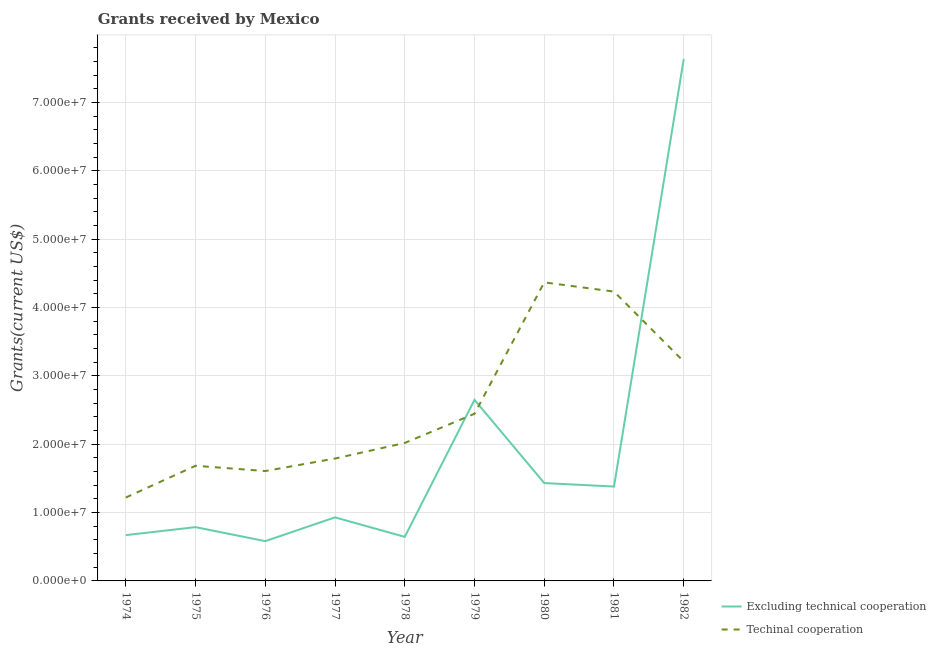What is the amount of grants received(excluding technical cooperation) in 1980?
Your answer should be compact. 1.43e+07. Across all years, what is the maximum amount of grants received(excluding technical cooperation)?
Offer a very short reply. 7.64e+07. Across all years, what is the minimum amount of grants received(excluding technical cooperation)?
Ensure brevity in your answer.  5.82e+06. In which year was the amount of grants received(including technical cooperation) maximum?
Keep it short and to the point. 1980. In which year was the amount of grants received(excluding technical cooperation) minimum?
Keep it short and to the point. 1976. What is the total amount of grants received(including technical cooperation) in the graph?
Provide a short and direct response. 2.26e+08. What is the difference between the amount of grants received(including technical cooperation) in 1974 and that in 1978?
Provide a succinct answer. -7.99e+06. What is the difference between the amount of grants received(excluding technical cooperation) in 1974 and the amount of grants received(including technical cooperation) in 1981?
Your answer should be very brief. -3.56e+07. What is the average amount of grants received(excluding technical cooperation) per year?
Offer a very short reply. 1.86e+07. In the year 1974, what is the difference between the amount of grants received(excluding technical cooperation) and amount of grants received(including technical cooperation)?
Provide a short and direct response. -5.50e+06. What is the ratio of the amount of grants received(excluding technical cooperation) in 1975 to that in 1982?
Ensure brevity in your answer.  0.1. What is the difference between the highest and the second highest amount of grants received(including technical cooperation)?
Your response must be concise. 1.35e+06. What is the difference between the highest and the lowest amount of grants received(including technical cooperation)?
Ensure brevity in your answer.  3.15e+07. In how many years, is the amount of grants received(excluding technical cooperation) greater than the average amount of grants received(excluding technical cooperation) taken over all years?
Keep it short and to the point. 2. How many lines are there?
Offer a terse response. 2. How many years are there in the graph?
Provide a short and direct response. 9. Are the values on the major ticks of Y-axis written in scientific E-notation?
Your response must be concise. Yes. Does the graph contain any zero values?
Offer a terse response. No. Where does the legend appear in the graph?
Provide a short and direct response. Bottom right. How are the legend labels stacked?
Give a very brief answer. Vertical. What is the title of the graph?
Your response must be concise. Grants received by Mexico. Does "Nitrous oxide emissions" appear as one of the legend labels in the graph?
Your answer should be very brief. No. What is the label or title of the Y-axis?
Offer a very short reply. Grants(current US$). What is the Grants(current US$) of Excluding technical cooperation in 1974?
Give a very brief answer. 6.70e+06. What is the Grants(current US$) in Techinal cooperation in 1974?
Your answer should be compact. 1.22e+07. What is the Grants(current US$) in Excluding technical cooperation in 1975?
Make the answer very short. 7.87e+06. What is the Grants(current US$) of Techinal cooperation in 1975?
Your answer should be compact. 1.68e+07. What is the Grants(current US$) of Excluding technical cooperation in 1976?
Provide a succinct answer. 5.82e+06. What is the Grants(current US$) of Techinal cooperation in 1976?
Your answer should be very brief. 1.61e+07. What is the Grants(current US$) in Excluding technical cooperation in 1977?
Ensure brevity in your answer.  9.30e+06. What is the Grants(current US$) of Techinal cooperation in 1977?
Ensure brevity in your answer.  1.79e+07. What is the Grants(current US$) in Excluding technical cooperation in 1978?
Ensure brevity in your answer.  6.45e+06. What is the Grants(current US$) in Techinal cooperation in 1978?
Give a very brief answer. 2.02e+07. What is the Grants(current US$) of Excluding technical cooperation in 1979?
Offer a terse response. 2.65e+07. What is the Grants(current US$) of Techinal cooperation in 1979?
Give a very brief answer. 2.45e+07. What is the Grants(current US$) of Excluding technical cooperation in 1980?
Offer a terse response. 1.43e+07. What is the Grants(current US$) in Techinal cooperation in 1980?
Provide a succinct answer. 4.37e+07. What is the Grants(current US$) of Excluding technical cooperation in 1981?
Your answer should be very brief. 1.38e+07. What is the Grants(current US$) in Techinal cooperation in 1981?
Provide a short and direct response. 4.23e+07. What is the Grants(current US$) in Excluding technical cooperation in 1982?
Your answer should be very brief. 7.64e+07. What is the Grants(current US$) of Techinal cooperation in 1982?
Offer a terse response. 3.21e+07. Across all years, what is the maximum Grants(current US$) in Excluding technical cooperation?
Provide a short and direct response. 7.64e+07. Across all years, what is the maximum Grants(current US$) in Techinal cooperation?
Offer a terse response. 4.37e+07. Across all years, what is the minimum Grants(current US$) in Excluding technical cooperation?
Keep it short and to the point. 5.82e+06. Across all years, what is the minimum Grants(current US$) in Techinal cooperation?
Provide a succinct answer. 1.22e+07. What is the total Grants(current US$) in Excluding technical cooperation in the graph?
Your response must be concise. 1.67e+08. What is the total Grants(current US$) of Techinal cooperation in the graph?
Provide a succinct answer. 2.26e+08. What is the difference between the Grants(current US$) of Excluding technical cooperation in 1974 and that in 1975?
Your answer should be compact. -1.17e+06. What is the difference between the Grants(current US$) in Techinal cooperation in 1974 and that in 1975?
Ensure brevity in your answer.  -4.65e+06. What is the difference between the Grants(current US$) of Excluding technical cooperation in 1974 and that in 1976?
Ensure brevity in your answer.  8.80e+05. What is the difference between the Grants(current US$) of Techinal cooperation in 1974 and that in 1976?
Keep it short and to the point. -3.88e+06. What is the difference between the Grants(current US$) of Excluding technical cooperation in 1974 and that in 1977?
Your answer should be compact. -2.60e+06. What is the difference between the Grants(current US$) in Techinal cooperation in 1974 and that in 1977?
Offer a terse response. -5.71e+06. What is the difference between the Grants(current US$) of Excluding technical cooperation in 1974 and that in 1978?
Provide a succinct answer. 2.50e+05. What is the difference between the Grants(current US$) of Techinal cooperation in 1974 and that in 1978?
Provide a succinct answer. -7.99e+06. What is the difference between the Grants(current US$) in Excluding technical cooperation in 1974 and that in 1979?
Provide a succinct answer. -1.98e+07. What is the difference between the Grants(current US$) of Techinal cooperation in 1974 and that in 1979?
Provide a short and direct response. -1.23e+07. What is the difference between the Grants(current US$) of Excluding technical cooperation in 1974 and that in 1980?
Keep it short and to the point. -7.62e+06. What is the difference between the Grants(current US$) of Techinal cooperation in 1974 and that in 1980?
Offer a terse response. -3.15e+07. What is the difference between the Grants(current US$) in Excluding technical cooperation in 1974 and that in 1981?
Your answer should be very brief. -7.11e+06. What is the difference between the Grants(current US$) in Techinal cooperation in 1974 and that in 1981?
Your answer should be very brief. -3.01e+07. What is the difference between the Grants(current US$) of Excluding technical cooperation in 1974 and that in 1982?
Your answer should be very brief. -6.97e+07. What is the difference between the Grants(current US$) in Techinal cooperation in 1974 and that in 1982?
Your answer should be compact. -1.99e+07. What is the difference between the Grants(current US$) of Excluding technical cooperation in 1975 and that in 1976?
Offer a very short reply. 2.05e+06. What is the difference between the Grants(current US$) in Techinal cooperation in 1975 and that in 1976?
Offer a very short reply. 7.70e+05. What is the difference between the Grants(current US$) of Excluding technical cooperation in 1975 and that in 1977?
Your answer should be very brief. -1.43e+06. What is the difference between the Grants(current US$) of Techinal cooperation in 1975 and that in 1977?
Provide a short and direct response. -1.06e+06. What is the difference between the Grants(current US$) in Excluding technical cooperation in 1975 and that in 1978?
Provide a short and direct response. 1.42e+06. What is the difference between the Grants(current US$) in Techinal cooperation in 1975 and that in 1978?
Keep it short and to the point. -3.34e+06. What is the difference between the Grants(current US$) in Excluding technical cooperation in 1975 and that in 1979?
Your response must be concise. -1.86e+07. What is the difference between the Grants(current US$) of Techinal cooperation in 1975 and that in 1979?
Provide a short and direct response. -7.61e+06. What is the difference between the Grants(current US$) in Excluding technical cooperation in 1975 and that in 1980?
Your response must be concise. -6.45e+06. What is the difference between the Grants(current US$) of Techinal cooperation in 1975 and that in 1980?
Ensure brevity in your answer.  -2.68e+07. What is the difference between the Grants(current US$) of Excluding technical cooperation in 1975 and that in 1981?
Provide a succinct answer. -5.94e+06. What is the difference between the Grants(current US$) in Techinal cooperation in 1975 and that in 1981?
Make the answer very short. -2.55e+07. What is the difference between the Grants(current US$) of Excluding technical cooperation in 1975 and that in 1982?
Provide a succinct answer. -6.85e+07. What is the difference between the Grants(current US$) of Techinal cooperation in 1975 and that in 1982?
Offer a terse response. -1.53e+07. What is the difference between the Grants(current US$) in Excluding technical cooperation in 1976 and that in 1977?
Keep it short and to the point. -3.48e+06. What is the difference between the Grants(current US$) in Techinal cooperation in 1976 and that in 1977?
Your answer should be compact. -1.83e+06. What is the difference between the Grants(current US$) in Excluding technical cooperation in 1976 and that in 1978?
Give a very brief answer. -6.30e+05. What is the difference between the Grants(current US$) of Techinal cooperation in 1976 and that in 1978?
Provide a short and direct response. -4.11e+06. What is the difference between the Grants(current US$) of Excluding technical cooperation in 1976 and that in 1979?
Make the answer very short. -2.07e+07. What is the difference between the Grants(current US$) of Techinal cooperation in 1976 and that in 1979?
Provide a succinct answer. -8.38e+06. What is the difference between the Grants(current US$) in Excluding technical cooperation in 1976 and that in 1980?
Give a very brief answer. -8.50e+06. What is the difference between the Grants(current US$) of Techinal cooperation in 1976 and that in 1980?
Make the answer very short. -2.76e+07. What is the difference between the Grants(current US$) of Excluding technical cooperation in 1976 and that in 1981?
Your response must be concise. -7.99e+06. What is the difference between the Grants(current US$) in Techinal cooperation in 1976 and that in 1981?
Keep it short and to the point. -2.63e+07. What is the difference between the Grants(current US$) in Excluding technical cooperation in 1976 and that in 1982?
Offer a terse response. -7.06e+07. What is the difference between the Grants(current US$) of Techinal cooperation in 1976 and that in 1982?
Keep it short and to the point. -1.60e+07. What is the difference between the Grants(current US$) of Excluding technical cooperation in 1977 and that in 1978?
Your answer should be compact. 2.85e+06. What is the difference between the Grants(current US$) in Techinal cooperation in 1977 and that in 1978?
Offer a very short reply. -2.28e+06. What is the difference between the Grants(current US$) in Excluding technical cooperation in 1977 and that in 1979?
Your response must be concise. -1.72e+07. What is the difference between the Grants(current US$) of Techinal cooperation in 1977 and that in 1979?
Ensure brevity in your answer.  -6.55e+06. What is the difference between the Grants(current US$) in Excluding technical cooperation in 1977 and that in 1980?
Provide a succinct answer. -5.02e+06. What is the difference between the Grants(current US$) of Techinal cooperation in 1977 and that in 1980?
Offer a terse response. -2.58e+07. What is the difference between the Grants(current US$) in Excluding technical cooperation in 1977 and that in 1981?
Provide a short and direct response. -4.51e+06. What is the difference between the Grants(current US$) of Techinal cooperation in 1977 and that in 1981?
Provide a short and direct response. -2.44e+07. What is the difference between the Grants(current US$) of Excluding technical cooperation in 1977 and that in 1982?
Your answer should be very brief. -6.71e+07. What is the difference between the Grants(current US$) of Techinal cooperation in 1977 and that in 1982?
Make the answer very short. -1.42e+07. What is the difference between the Grants(current US$) of Excluding technical cooperation in 1978 and that in 1979?
Your answer should be very brief. -2.00e+07. What is the difference between the Grants(current US$) in Techinal cooperation in 1978 and that in 1979?
Your response must be concise. -4.27e+06. What is the difference between the Grants(current US$) of Excluding technical cooperation in 1978 and that in 1980?
Give a very brief answer. -7.87e+06. What is the difference between the Grants(current US$) of Techinal cooperation in 1978 and that in 1980?
Offer a very short reply. -2.35e+07. What is the difference between the Grants(current US$) in Excluding technical cooperation in 1978 and that in 1981?
Offer a terse response. -7.36e+06. What is the difference between the Grants(current US$) in Techinal cooperation in 1978 and that in 1981?
Your answer should be compact. -2.22e+07. What is the difference between the Grants(current US$) in Excluding technical cooperation in 1978 and that in 1982?
Give a very brief answer. -6.99e+07. What is the difference between the Grants(current US$) of Techinal cooperation in 1978 and that in 1982?
Offer a very short reply. -1.19e+07. What is the difference between the Grants(current US$) of Excluding technical cooperation in 1979 and that in 1980?
Keep it short and to the point. 1.22e+07. What is the difference between the Grants(current US$) in Techinal cooperation in 1979 and that in 1980?
Your response must be concise. -1.92e+07. What is the difference between the Grants(current US$) of Excluding technical cooperation in 1979 and that in 1981?
Offer a very short reply. 1.27e+07. What is the difference between the Grants(current US$) of Techinal cooperation in 1979 and that in 1981?
Provide a short and direct response. -1.79e+07. What is the difference between the Grants(current US$) of Excluding technical cooperation in 1979 and that in 1982?
Your response must be concise. -4.99e+07. What is the difference between the Grants(current US$) in Techinal cooperation in 1979 and that in 1982?
Your answer should be very brief. -7.65e+06. What is the difference between the Grants(current US$) of Excluding technical cooperation in 1980 and that in 1981?
Your response must be concise. 5.10e+05. What is the difference between the Grants(current US$) of Techinal cooperation in 1980 and that in 1981?
Ensure brevity in your answer.  1.35e+06. What is the difference between the Grants(current US$) of Excluding technical cooperation in 1980 and that in 1982?
Your response must be concise. -6.21e+07. What is the difference between the Grants(current US$) of Techinal cooperation in 1980 and that in 1982?
Your response must be concise. 1.16e+07. What is the difference between the Grants(current US$) in Excluding technical cooperation in 1981 and that in 1982?
Your response must be concise. -6.26e+07. What is the difference between the Grants(current US$) of Techinal cooperation in 1981 and that in 1982?
Offer a terse response. 1.02e+07. What is the difference between the Grants(current US$) in Excluding technical cooperation in 1974 and the Grants(current US$) in Techinal cooperation in 1975?
Your response must be concise. -1.02e+07. What is the difference between the Grants(current US$) in Excluding technical cooperation in 1974 and the Grants(current US$) in Techinal cooperation in 1976?
Give a very brief answer. -9.38e+06. What is the difference between the Grants(current US$) of Excluding technical cooperation in 1974 and the Grants(current US$) of Techinal cooperation in 1977?
Your answer should be very brief. -1.12e+07. What is the difference between the Grants(current US$) in Excluding technical cooperation in 1974 and the Grants(current US$) in Techinal cooperation in 1978?
Your answer should be compact. -1.35e+07. What is the difference between the Grants(current US$) of Excluding technical cooperation in 1974 and the Grants(current US$) of Techinal cooperation in 1979?
Provide a short and direct response. -1.78e+07. What is the difference between the Grants(current US$) of Excluding technical cooperation in 1974 and the Grants(current US$) of Techinal cooperation in 1980?
Provide a short and direct response. -3.70e+07. What is the difference between the Grants(current US$) of Excluding technical cooperation in 1974 and the Grants(current US$) of Techinal cooperation in 1981?
Ensure brevity in your answer.  -3.56e+07. What is the difference between the Grants(current US$) in Excluding technical cooperation in 1974 and the Grants(current US$) in Techinal cooperation in 1982?
Keep it short and to the point. -2.54e+07. What is the difference between the Grants(current US$) in Excluding technical cooperation in 1975 and the Grants(current US$) in Techinal cooperation in 1976?
Make the answer very short. -8.21e+06. What is the difference between the Grants(current US$) in Excluding technical cooperation in 1975 and the Grants(current US$) in Techinal cooperation in 1977?
Your answer should be compact. -1.00e+07. What is the difference between the Grants(current US$) of Excluding technical cooperation in 1975 and the Grants(current US$) of Techinal cooperation in 1978?
Offer a very short reply. -1.23e+07. What is the difference between the Grants(current US$) in Excluding technical cooperation in 1975 and the Grants(current US$) in Techinal cooperation in 1979?
Keep it short and to the point. -1.66e+07. What is the difference between the Grants(current US$) in Excluding technical cooperation in 1975 and the Grants(current US$) in Techinal cooperation in 1980?
Keep it short and to the point. -3.58e+07. What is the difference between the Grants(current US$) of Excluding technical cooperation in 1975 and the Grants(current US$) of Techinal cooperation in 1981?
Provide a succinct answer. -3.45e+07. What is the difference between the Grants(current US$) of Excluding technical cooperation in 1975 and the Grants(current US$) of Techinal cooperation in 1982?
Your answer should be compact. -2.42e+07. What is the difference between the Grants(current US$) in Excluding technical cooperation in 1976 and the Grants(current US$) in Techinal cooperation in 1977?
Your answer should be compact. -1.21e+07. What is the difference between the Grants(current US$) of Excluding technical cooperation in 1976 and the Grants(current US$) of Techinal cooperation in 1978?
Ensure brevity in your answer.  -1.44e+07. What is the difference between the Grants(current US$) in Excluding technical cooperation in 1976 and the Grants(current US$) in Techinal cooperation in 1979?
Give a very brief answer. -1.86e+07. What is the difference between the Grants(current US$) of Excluding technical cooperation in 1976 and the Grants(current US$) of Techinal cooperation in 1980?
Give a very brief answer. -3.79e+07. What is the difference between the Grants(current US$) in Excluding technical cooperation in 1976 and the Grants(current US$) in Techinal cooperation in 1981?
Your response must be concise. -3.65e+07. What is the difference between the Grants(current US$) in Excluding technical cooperation in 1976 and the Grants(current US$) in Techinal cooperation in 1982?
Offer a very short reply. -2.63e+07. What is the difference between the Grants(current US$) in Excluding technical cooperation in 1977 and the Grants(current US$) in Techinal cooperation in 1978?
Your answer should be very brief. -1.09e+07. What is the difference between the Grants(current US$) of Excluding technical cooperation in 1977 and the Grants(current US$) of Techinal cooperation in 1979?
Make the answer very short. -1.52e+07. What is the difference between the Grants(current US$) in Excluding technical cooperation in 1977 and the Grants(current US$) in Techinal cooperation in 1980?
Ensure brevity in your answer.  -3.44e+07. What is the difference between the Grants(current US$) of Excluding technical cooperation in 1977 and the Grants(current US$) of Techinal cooperation in 1981?
Give a very brief answer. -3.30e+07. What is the difference between the Grants(current US$) in Excluding technical cooperation in 1977 and the Grants(current US$) in Techinal cooperation in 1982?
Your answer should be compact. -2.28e+07. What is the difference between the Grants(current US$) of Excluding technical cooperation in 1978 and the Grants(current US$) of Techinal cooperation in 1979?
Your answer should be compact. -1.80e+07. What is the difference between the Grants(current US$) in Excluding technical cooperation in 1978 and the Grants(current US$) in Techinal cooperation in 1980?
Your response must be concise. -3.72e+07. What is the difference between the Grants(current US$) in Excluding technical cooperation in 1978 and the Grants(current US$) in Techinal cooperation in 1981?
Your response must be concise. -3.59e+07. What is the difference between the Grants(current US$) in Excluding technical cooperation in 1978 and the Grants(current US$) in Techinal cooperation in 1982?
Give a very brief answer. -2.57e+07. What is the difference between the Grants(current US$) in Excluding technical cooperation in 1979 and the Grants(current US$) in Techinal cooperation in 1980?
Your response must be concise. -1.72e+07. What is the difference between the Grants(current US$) in Excluding technical cooperation in 1979 and the Grants(current US$) in Techinal cooperation in 1981?
Keep it short and to the point. -1.58e+07. What is the difference between the Grants(current US$) of Excluding technical cooperation in 1979 and the Grants(current US$) of Techinal cooperation in 1982?
Provide a succinct answer. -5.61e+06. What is the difference between the Grants(current US$) in Excluding technical cooperation in 1980 and the Grants(current US$) in Techinal cooperation in 1981?
Your answer should be very brief. -2.80e+07. What is the difference between the Grants(current US$) in Excluding technical cooperation in 1980 and the Grants(current US$) in Techinal cooperation in 1982?
Your answer should be very brief. -1.78e+07. What is the difference between the Grants(current US$) in Excluding technical cooperation in 1981 and the Grants(current US$) in Techinal cooperation in 1982?
Give a very brief answer. -1.83e+07. What is the average Grants(current US$) in Excluding technical cooperation per year?
Give a very brief answer. 1.86e+07. What is the average Grants(current US$) in Techinal cooperation per year?
Your response must be concise. 2.51e+07. In the year 1974, what is the difference between the Grants(current US$) of Excluding technical cooperation and Grants(current US$) of Techinal cooperation?
Offer a terse response. -5.50e+06. In the year 1975, what is the difference between the Grants(current US$) in Excluding technical cooperation and Grants(current US$) in Techinal cooperation?
Offer a terse response. -8.98e+06. In the year 1976, what is the difference between the Grants(current US$) in Excluding technical cooperation and Grants(current US$) in Techinal cooperation?
Make the answer very short. -1.03e+07. In the year 1977, what is the difference between the Grants(current US$) in Excluding technical cooperation and Grants(current US$) in Techinal cooperation?
Your answer should be compact. -8.61e+06. In the year 1978, what is the difference between the Grants(current US$) in Excluding technical cooperation and Grants(current US$) in Techinal cooperation?
Make the answer very short. -1.37e+07. In the year 1979, what is the difference between the Grants(current US$) of Excluding technical cooperation and Grants(current US$) of Techinal cooperation?
Offer a very short reply. 2.04e+06. In the year 1980, what is the difference between the Grants(current US$) of Excluding technical cooperation and Grants(current US$) of Techinal cooperation?
Your answer should be very brief. -2.94e+07. In the year 1981, what is the difference between the Grants(current US$) in Excluding technical cooperation and Grants(current US$) in Techinal cooperation?
Your answer should be compact. -2.85e+07. In the year 1982, what is the difference between the Grants(current US$) of Excluding technical cooperation and Grants(current US$) of Techinal cooperation?
Your answer should be very brief. 4.43e+07. What is the ratio of the Grants(current US$) of Excluding technical cooperation in 1974 to that in 1975?
Provide a succinct answer. 0.85. What is the ratio of the Grants(current US$) in Techinal cooperation in 1974 to that in 1975?
Ensure brevity in your answer.  0.72. What is the ratio of the Grants(current US$) of Excluding technical cooperation in 1974 to that in 1976?
Your answer should be very brief. 1.15. What is the ratio of the Grants(current US$) in Techinal cooperation in 1974 to that in 1976?
Your response must be concise. 0.76. What is the ratio of the Grants(current US$) in Excluding technical cooperation in 1974 to that in 1977?
Ensure brevity in your answer.  0.72. What is the ratio of the Grants(current US$) of Techinal cooperation in 1974 to that in 1977?
Provide a succinct answer. 0.68. What is the ratio of the Grants(current US$) of Excluding technical cooperation in 1974 to that in 1978?
Make the answer very short. 1.04. What is the ratio of the Grants(current US$) of Techinal cooperation in 1974 to that in 1978?
Offer a terse response. 0.6. What is the ratio of the Grants(current US$) of Excluding technical cooperation in 1974 to that in 1979?
Provide a short and direct response. 0.25. What is the ratio of the Grants(current US$) of Techinal cooperation in 1974 to that in 1979?
Give a very brief answer. 0.5. What is the ratio of the Grants(current US$) in Excluding technical cooperation in 1974 to that in 1980?
Your answer should be compact. 0.47. What is the ratio of the Grants(current US$) in Techinal cooperation in 1974 to that in 1980?
Your response must be concise. 0.28. What is the ratio of the Grants(current US$) in Excluding technical cooperation in 1974 to that in 1981?
Offer a terse response. 0.49. What is the ratio of the Grants(current US$) of Techinal cooperation in 1974 to that in 1981?
Your answer should be very brief. 0.29. What is the ratio of the Grants(current US$) in Excluding technical cooperation in 1974 to that in 1982?
Provide a short and direct response. 0.09. What is the ratio of the Grants(current US$) of Techinal cooperation in 1974 to that in 1982?
Ensure brevity in your answer.  0.38. What is the ratio of the Grants(current US$) in Excluding technical cooperation in 1975 to that in 1976?
Keep it short and to the point. 1.35. What is the ratio of the Grants(current US$) of Techinal cooperation in 1975 to that in 1976?
Ensure brevity in your answer.  1.05. What is the ratio of the Grants(current US$) of Excluding technical cooperation in 1975 to that in 1977?
Offer a very short reply. 0.85. What is the ratio of the Grants(current US$) in Techinal cooperation in 1975 to that in 1977?
Your answer should be very brief. 0.94. What is the ratio of the Grants(current US$) in Excluding technical cooperation in 1975 to that in 1978?
Your answer should be very brief. 1.22. What is the ratio of the Grants(current US$) of Techinal cooperation in 1975 to that in 1978?
Make the answer very short. 0.83. What is the ratio of the Grants(current US$) in Excluding technical cooperation in 1975 to that in 1979?
Your answer should be very brief. 0.3. What is the ratio of the Grants(current US$) in Techinal cooperation in 1975 to that in 1979?
Provide a short and direct response. 0.69. What is the ratio of the Grants(current US$) in Excluding technical cooperation in 1975 to that in 1980?
Ensure brevity in your answer.  0.55. What is the ratio of the Grants(current US$) in Techinal cooperation in 1975 to that in 1980?
Offer a terse response. 0.39. What is the ratio of the Grants(current US$) in Excluding technical cooperation in 1975 to that in 1981?
Offer a very short reply. 0.57. What is the ratio of the Grants(current US$) in Techinal cooperation in 1975 to that in 1981?
Provide a succinct answer. 0.4. What is the ratio of the Grants(current US$) in Excluding technical cooperation in 1975 to that in 1982?
Make the answer very short. 0.1. What is the ratio of the Grants(current US$) of Techinal cooperation in 1975 to that in 1982?
Offer a terse response. 0.52. What is the ratio of the Grants(current US$) in Excluding technical cooperation in 1976 to that in 1977?
Make the answer very short. 0.63. What is the ratio of the Grants(current US$) of Techinal cooperation in 1976 to that in 1977?
Your response must be concise. 0.9. What is the ratio of the Grants(current US$) in Excluding technical cooperation in 1976 to that in 1978?
Offer a terse response. 0.9. What is the ratio of the Grants(current US$) in Techinal cooperation in 1976 to that in 1978?
Offer a very short reply. 0.8. What is the ratio of the Grants(current US$) of Excluding technical cooperation in 1976 to that in 1979?
Offer a very short reply. 0.22. What is the ratio of the Grants(current US$) in Techinal cooperation in 1976 to that in 1979?
Provide a short and direct response. 0.66. What is the ratio of the Grants(current US$) in Excluding technical cooperation in 1976 to that in 1980?
Provide a succinct answer. 0.41. What is the ratio of the Grants(current US$) in Techinal cooperation in 1976 to that in 1980?
Your answer should be compact. 0.37. What is the ratio of the Grants(current US$) of Excluding technical cooperation in 1976 to that in 1981?
Provide a succinct answer. 0.42. What is the ratio of the Grants(current US$) in Techinal cooperation in 1976 to that in 1981?
Make the answer very short. 0.38. What is the ratio of the Grants(current US$) of Excluding technical cooperation in 1976 to that in 1982?
Your response must be concise. 0.08. What is the ratio of the Grants(current US$) of Techinal cooperation in 1976 to that in 1982?
Provide a short and direct response. 0.5. What is the ratio of the Grants(current US$) in Excluding technical cooperation in 1977 to that in 1978?
Offer a terse response. 1.44. What is the ratio of the Grants(current US$) in Techinal cooperation in 1977 to that in 1978?
Your answer should be compact. 0.89. What is the ratio of the Grants(current US$) of Excluding technical cooperation in 1977 to that in 1979?
Make the answer very short. 0.35. What is the ratio of the Grants(current US$) of Techinal cooperation in 1977 to that in 1979?
Your answer should be compact. 0.73. What is the ratio of the Grants(current US$) in Excluding technical cooperation in 1977 to that in 1980?
Ensure brevity in your answer.  0.65. What is the ratio of the Grants(current US$) of Techinal cooperation in 1977 to that in 1980?
Make the answer very short. 0.41. What is the ratio of the Grants(current US$) in Excluding technical cooperation in 1977 to that in 1981?
Give a very brief answer. 0.67. What is the ratio of the Grants(current US$) in Techinal cooperation in 1977 to that in 1981?
Offer a very short reply. 0.42. What is the ratio of the Grants(current US$) in Excluding technical cooperation in 1977 to that in 1982?
Your answer should be very brief. 0.12. What is the ratio of the Grants(current US$) in Techinal cooperation in 1977 to that in 1982?
Your answer should be very brief. 0.56. What is the ratio of the Grants(current US$) of Excluding technical cooperation in 1978 to that in 1979?
Provide a short and direct response. 0.24. What is the ratio of the Grants(current US$) in Techinal cooperation in 1978 to that in 1979?
Your response must be concise. 0.83. What is the ratio of the Grants(current US$) in Excluding technical cooperation in 1978 to that in 1980?
Provide a succinct answer. 0.45. What is the ratio of the Grants(current US$) in Techinal cooperation in 1978 to that in 1980?
Offer a terse response. 0.46. What is the ratio of the Grants(current US$) in Excluding technical cooperation in 1978 to that in 1981?
Your answer should be very brief. 0.47. What is the ratio of the Grants(current US$) of Techinal cooperation in 1978 to that in 1981?
Your response must be concise. 0.48. What is the ratio of the Grants(current US$) of Excluding technical cooperation in 1978 to that in 1982?
Offer a terse response. 0.08. What is the ratio of the Grants(current US$) of Techinal cooperation in 1978 to that in 1982?
Keep it short and to the point. 0.63. What is the ratio of the Grants(current US$) of Excluding technical cooperation in 1979 to that in 1980?
Offer a terse response. 1.85. What is the ratio of the Grants(current US$) of Techinal cooperation in 1979 to that in 1980?
Ensure brevity in your answer.  0.56. What is the ratio of the Grants(current US$) in Excluding technical cooperation in 1979 to that in 1981?
Provide a short and direct response. 1.92. What is the ratio of the Grants(current US$) in Techinal cooperation in 1979 to that in 1981?
Offer a very short reply. 0.58. What is the ratio of the Grants(current US$) in Excluding technical cooperation in 1979 to that in 1982?
Provide a short and direct response. 0.35. What is the ratio of the Grants(current US$) in Techinal cooperation in 1979 to that in 1982?
Provide a succinct answer. 0.76. What is the ratio of the Grants(current US$) of Excluding technical cooperation in 1980 to that in 1981?
Your response must be concise. 1.04. What is the ratio of the Grants(current US$) in Techinal cooperation in 1980 to that in 1981?
Offer a very short reply. 1.03. What is the ratio of the Grants(current US$) in Excluding technical cooperation in 1980 to that in 1982?
Give a very brief answer. 0.19. What is the ratio of the Grants(current US$) of Techinal cooperation in 1980 to that in 1982?
Your response must be concise. 1.36. What is the ratio of the Grants(current US$) of Excluding technical cooperation in 1981 to that in 1982?
Provide a succinct answer. 0.18. What is the ratio of the Grants(current US$) of Techinal cooperation in 1981 to that in 1982?
Keep it short and to the point. 1.32. What is the difference between the highest and the second highest Grants(current US$) in Excluding technical cooperation?
Keep it short and to the point. 4.99e+07. What is the difference between the highest and the second highest Grants(current US$) in Techinal cooperation?
Provide a short and direct response. 1.35e+06. What is the difference between the highest and the lowest Grants(current US$) in Excluding technical cooperation?
Offer a terse response. 7.06e+07. What is the difference between the highest and the lowest Grants(current US$) of Techinal cooperation?
Give a very brief answer. 3.15e+07. 